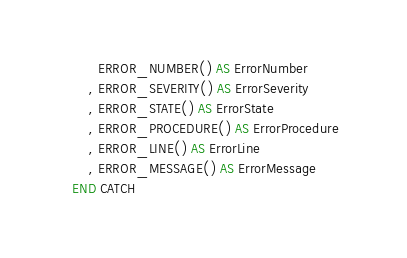<code> <loc_0><loc_0><loc_500><loc_500><_SQL_>      ERROR_NUMBER() AS ErrorNumber  
    , ERROR_SEVERITY() AS ErrorSeverity  
    , ERROR_STATE() AS ErrorState  
    , ERROR_PROCEDURE() AS ErrorProcedure  
    , ERROR_LINE() AS ErrorLine  
    , ERROR_MESSAGE() AS ErrorMessage 
END CATCH
</code> 